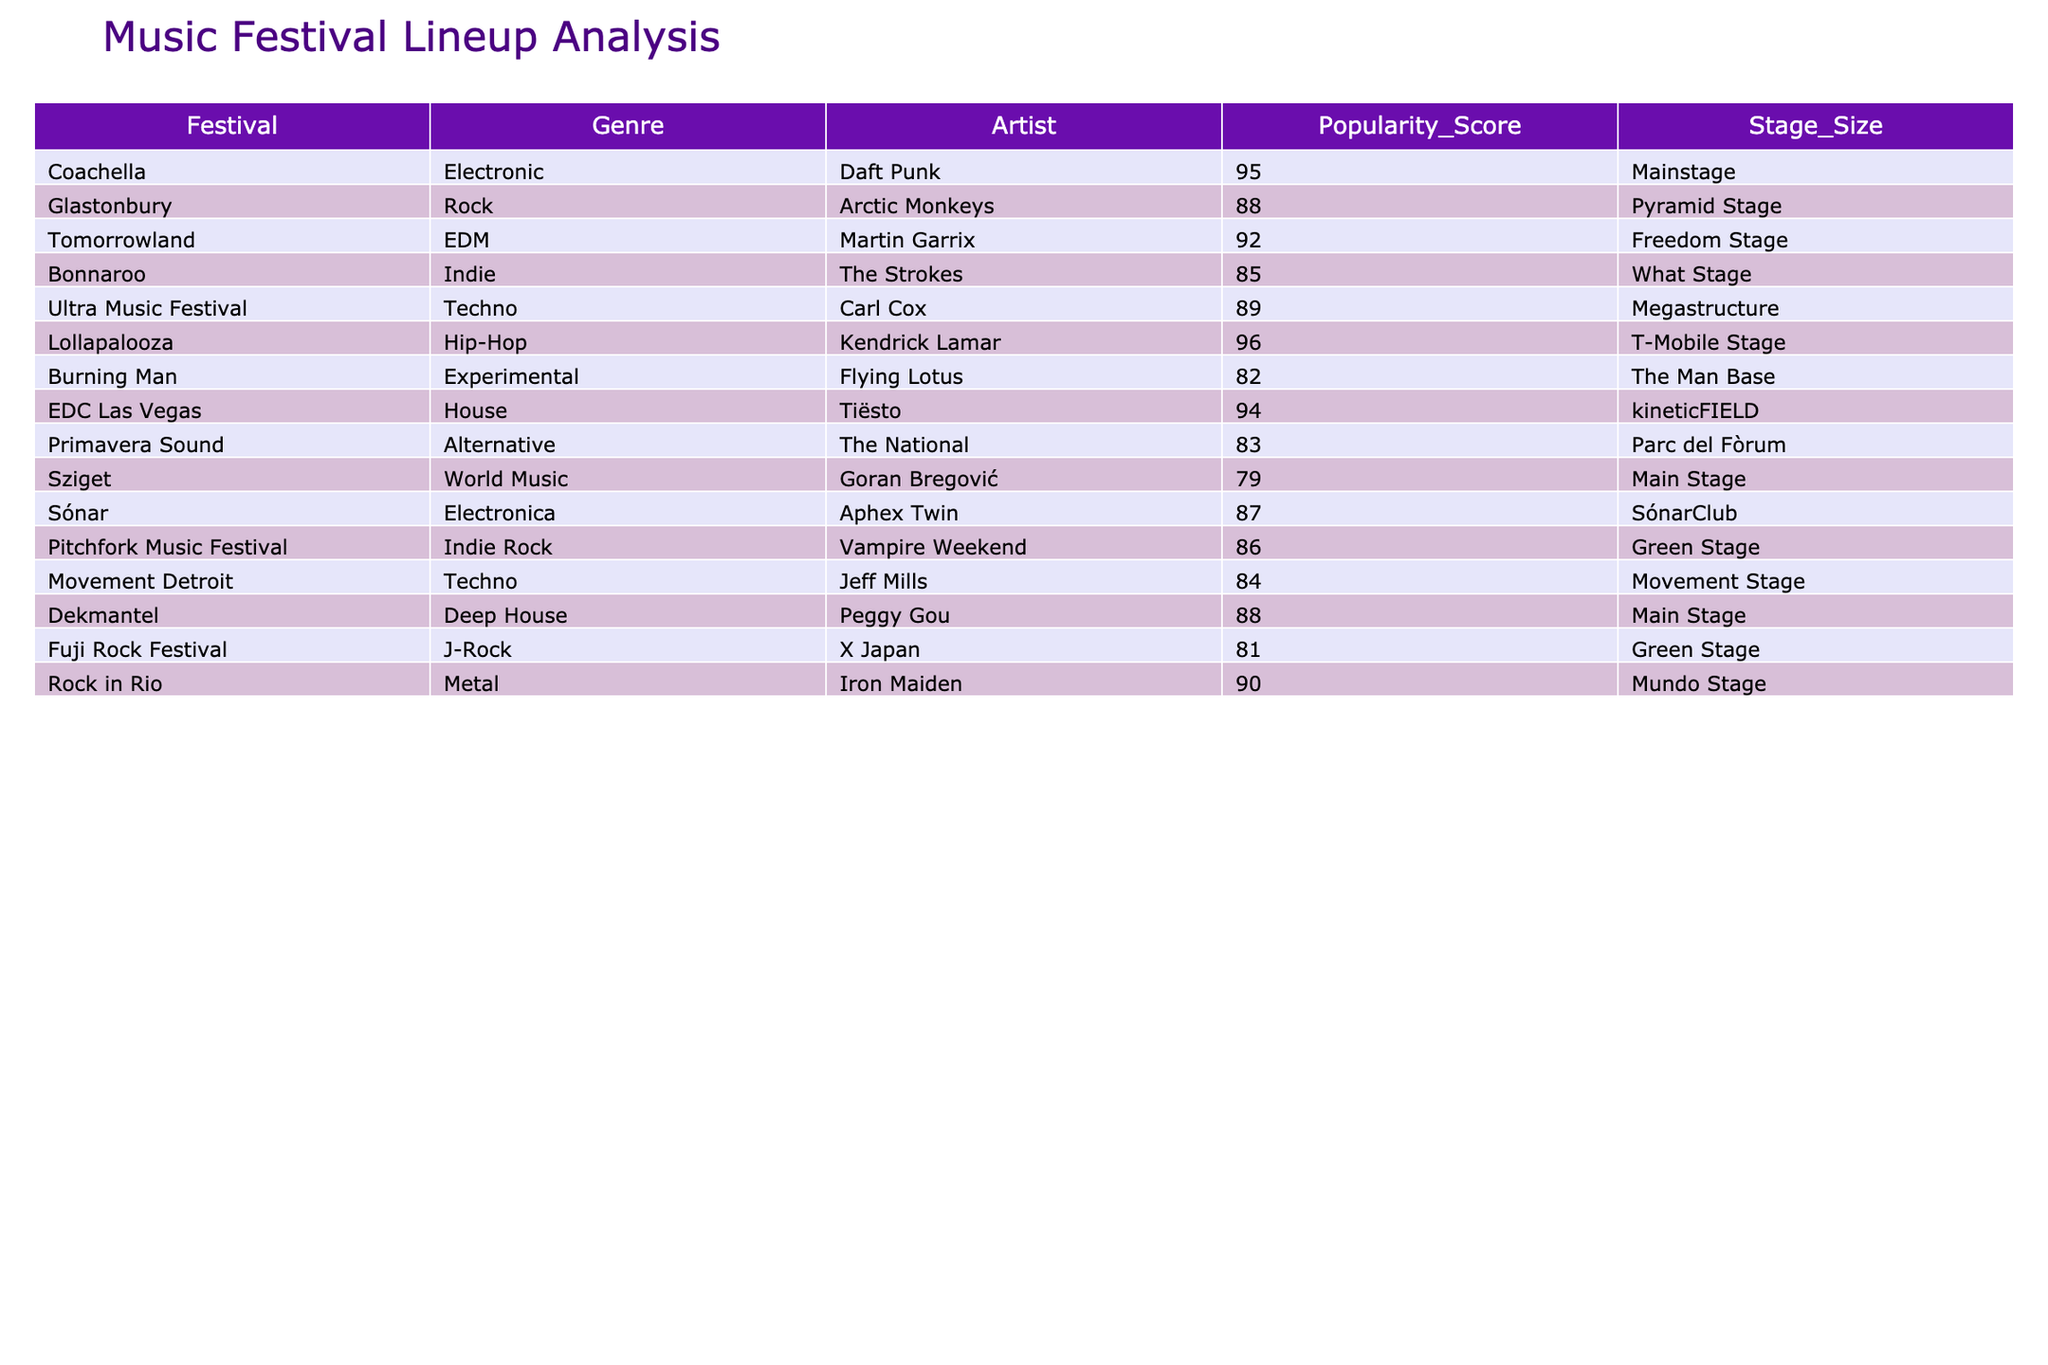What is the genre of the artist Daft Punk? By looking at the row that contains Daft Punk, we can see that the genre listed is "Electronic."
Answer: Electronic Which artist has the highest popularity score? Scanning through the popularity scores in the table, we find that Kendrick Lamar has the highest score of 96.
Answer: Kendrick Lamar What is the average popularity score of artists in the Rock genre? The only artist in the Rock genre is Arctic Monkeys with a score of 88. Therefore, the average is 88/1 = 88.
Answer: 88 Does any artist in the table have a popularity score of 80 or below? Looking at the popularity scores, only Flying Lotus has a score of 82, which is below 80.
Answer: No Which festival has the smallest stage size for its lineup? By examining the Stage Size column, we note that the festival with the smallest stage size listed is Burning Man, which uses "The Man Base."
Answer: The Man Base What is the total number of artists from the Techno genre? There are two artists in the Techno genre listed in the table: Carl Cox and Jeff Mills.
Answer: 2 Is there any festival featuring artists from both the Indie and Hip-Hop genres? In the table, Bonnaroo features The Strokes (Indie) and Lollapalooza features Kendrick Lamar (Hip-Hop). Therefore, both genres are represented across different festivals, but not within the same one.
Answer: No What is the difference in popularity scores between the artist with the highest and lowest score? The highest popularity score is held by Kendrick Lamar (96) and the lowest is Goran Bregović (79). The difference is 96 - 79 = 17.
Answer: 17 Which stage is used by Daft Punk at Coachella? Referring to the row for Coachella, Daft Punk is scheduled to perform on the "Mainstage."
Answer: Mainstage Can you list all genres that have an average popularity score of 85 or higher? We can calculate the average scores for each genre: Electronic (95), Rock (88), EDM (92), Hip-Hop (96), and House (94) all meet or exceed 85, while the others do not. Thus, the answer is Electronic, Rock, EDM, Hip-Hop, and House.
Answer: Electronic, Rock, EDM, Hip-Hop, House What is the stage size for the artist Tiësto? By checking the relevant row for Tiësto, we find that he is performing at "kineticFIELD."
Answer: kineticFIELD 